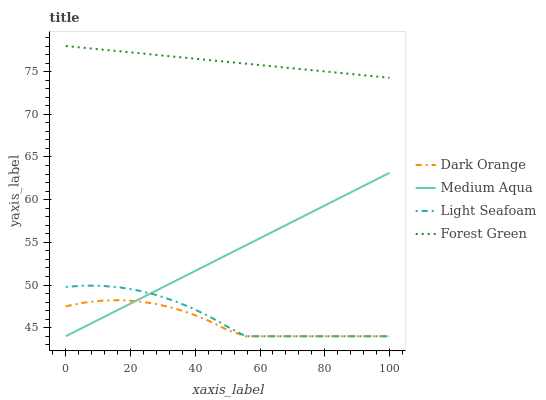Does Dark Orange have the minimum area under the curve?
Answer yes or no. Yes. Does Forest Green have the maximum area under the curve?
Answer yes or no. Yes. Does Light Seafoam have the minimum area under the curve?
Answer yes or no. No. Does Light Seafoam have the maximum area under the curve?
Answer yes or no. No. Is Medium Aqua the smoothest?
Answer yes or no. Yes. Is Light Seafoam the roughest?
Answer yes or no. Yes. Is Forest Green the smoothest?
Answer yes or no. No. Is Forest Green the roughest?
Answer yes or no. No. Does Dark Orange have the lowest value?
Answer yes or no. Yes. Does Forest Green have the lowest value?
Answer yes or no. No. Does Forest Green have the highest value?
Answer yes or no. Yes. Does Light Seafoam have the highest value?
Answer yes or no. No. Is Medium Aqua less than Forest Green?
Answer yes or no. Yes. Is Forest Green greater than Dark Orange?
Answer yes or no. Yes. Does Medium Aqua intersect Dark Orange?
Answer yes or no. Yes. Is Medium Aqua less than Dark Orange?
Answer yes or no. No. Is Medium Aqua greater than Dark Orange?
Answer yes or no. No. Does Medium Aqua intersect Forest Green?
Answer yes or no. No. 